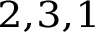Convert formula to latex. <formula><loc_0><loc_0><loc_500><loc_500>^ { 2 , 3 , 1 }</formula> 